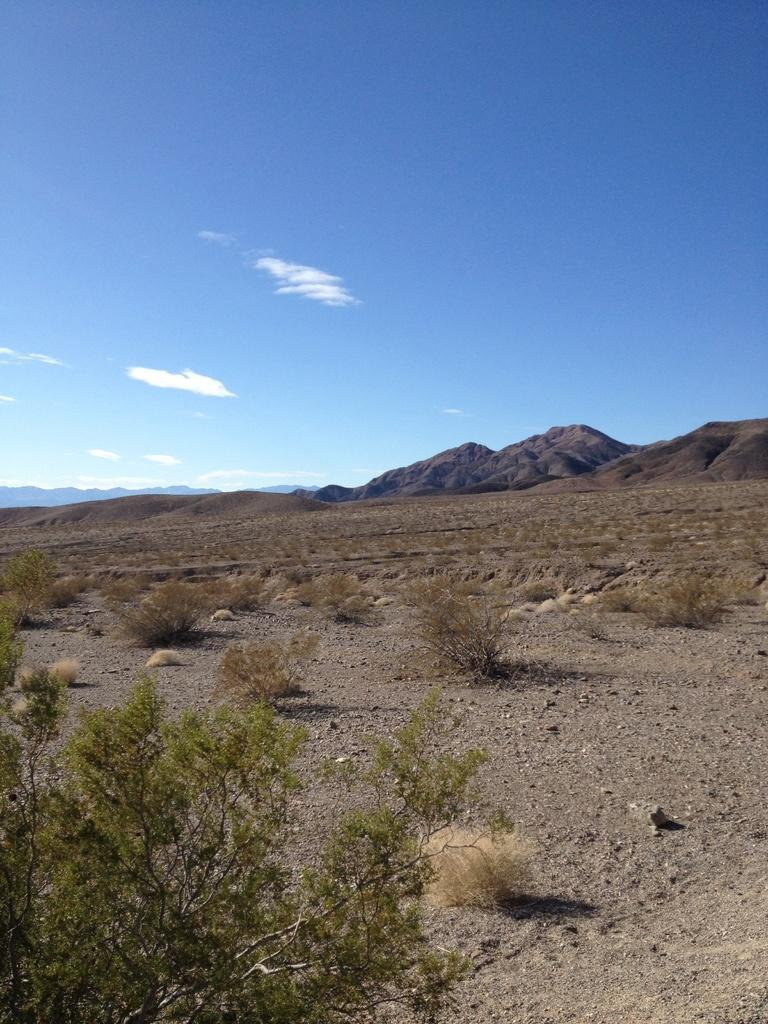What type of terrain is depicted in the image? There is a land in the image. What can be found on the land? There are plants on the land. What is visible in the background of the image? There are mountains and the sky in the background of the image. Can you see a yoke being used by the plants on the land? There is no yoke present in the image. 